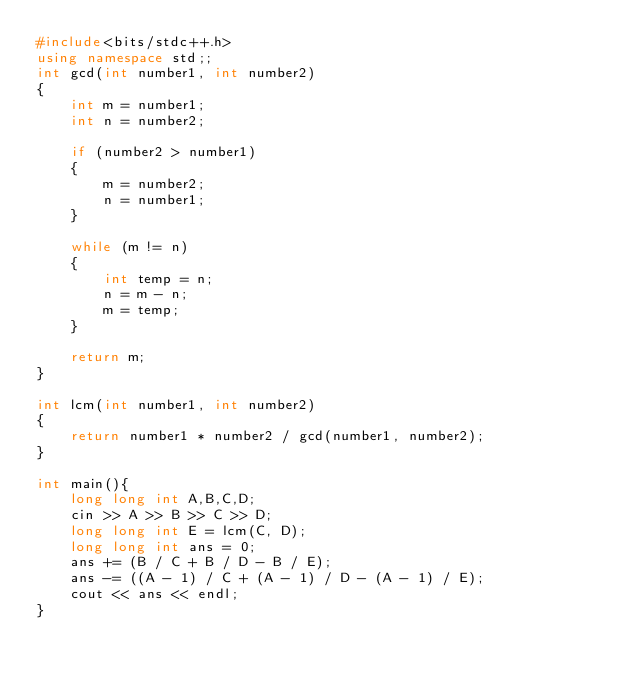<code> <loc_0><loc_0><loc_500><loc_500><_C++_>#include<bits/stdc++.h>
using namespace std;;
int gcd(int number1, int number2)
{
    int m = number1;
    int n = number2;

    if (number2 > number1)
    {
        m = number2;
        n = number1;
    }

    while (m != n)
    {
        int temp = n;
        n = m - n;
        m = temp;
    }

    return m;
}

int lcm(int number1, int number2)
{
    return number1 * number2 / gcd(number1, number2);
}

int main(){
    long long int A,B,C,D;
    cin >> A >> B >> C >> D;
    long long int E = lcm(C, D);
    long long int ans = 0;
    ans += (B / C + B / D - B / E);
    ans -= ((A - 1) / C + (A - 1) / D - (A - 1) / E);
    cout << ans << endl;
}
</code> 